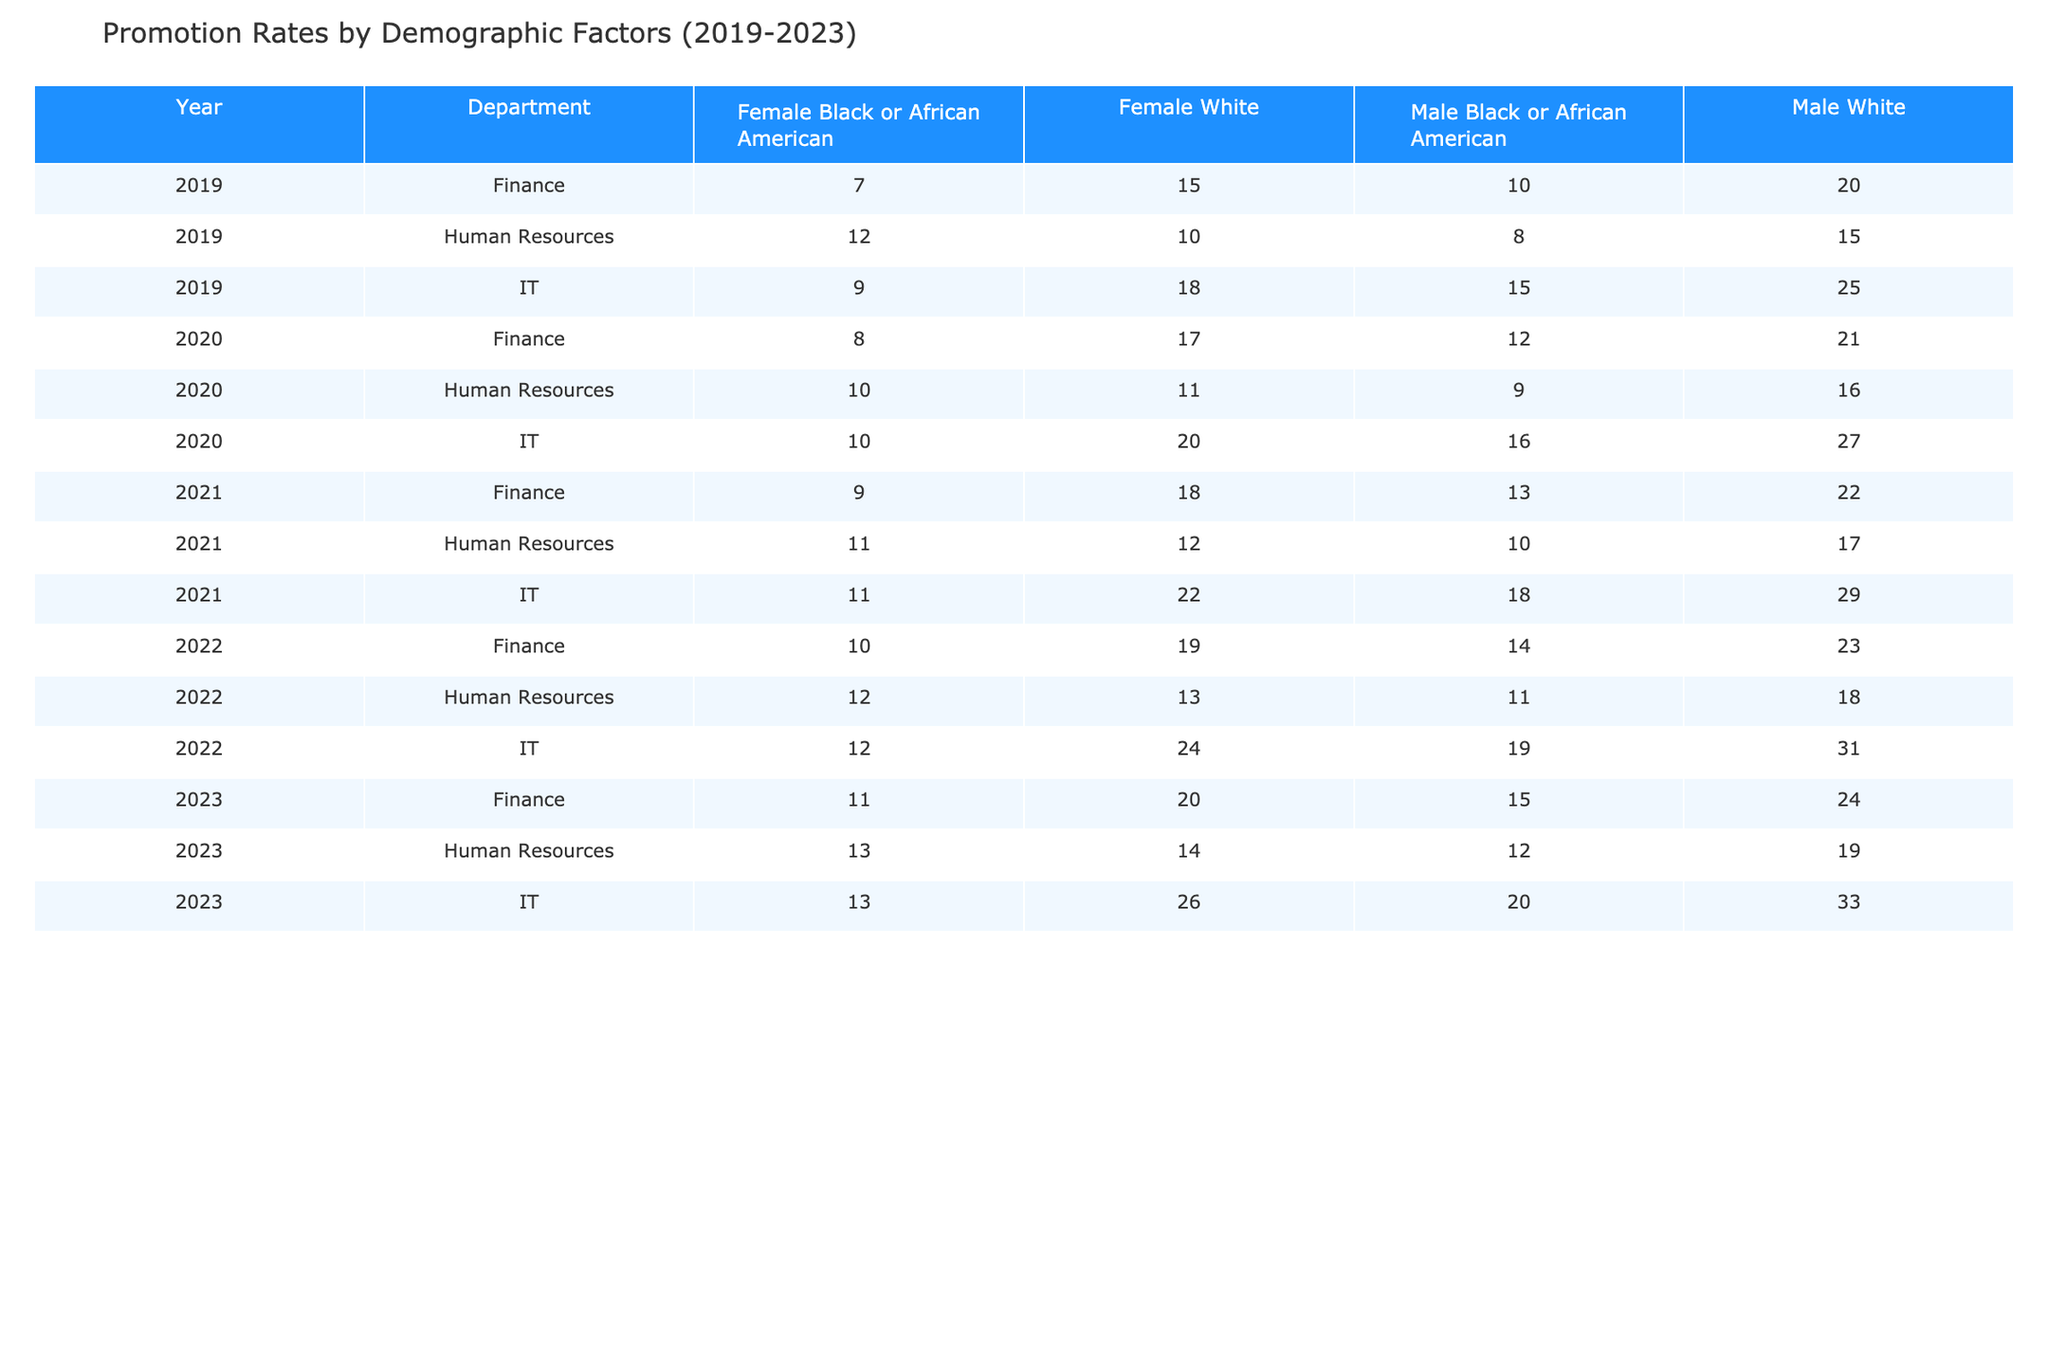What was the promotion rate for females of White ethnicity in IT in 2021? In the table, I locate the row for the year 2021, department IT, and find the column for females of White ethnicity. The promotion rate listed is 22.
Answer: 22 Which department had the highest promotion rate for Black or African American males in 2023? Looking at the year 2023, I check the promotion rates for Black or African American males across all departments. The highest rate is 20 in the IT department.
Answer: IT What is the average promotion rate for female employees (of all ethnicities combined) in Finance from 2019 to 2023? First, I sum the promotion rates for female employees in Finance over the years: 15 + 17 + 18 + 19 + 20 = 89. There are 5 data points, so I divide 89 by 5. The average is 89/5 = 17.8.
Answer: 17.8 Did the promotion rate for male employees of White ethnicity in Human Resources increase every year from 2019 to 2023? I examine the promotion rates for White males in Human Resources: 15 in 2019, 16 in 2020, 17 in 2021, 18 in 2022, and 19 in 2023. Since these values are increasing each year, the answer is yes.
Answer: Yes What was the difference in promotion rates for White females in IT between 2019 and 2022? I find the promotion rates for White females in IT. In 2019, it was 18, and in 2022, it was 24. The difference is calculated by subtracting the 2019 rate from the 2022 rate: 24 - 18 = 6.
Answer: 6 What was the highest promotion rate recorded for any demographic in Finance during the years 2019-2023? I scan the promotion rates in the Finance department for all years, identifying the highest value listed, which is 24 for White males in 2023.
Answer: 24 How did the promotion rate for Black or African American females in Human Resources change from 2019 to 2023? I check the rates for Black or African American females in Human Resources: 12 in 2019, 10 in 2020, 11 in 2021, 12 in 2022, and 13 in 2023. It shows an overall increase from 12 to 13 over the period.
Answer: Increased What is the overall trend in promotion rates for males of Black or African American ethnicity in the IT department from 2019 to 2023? I observe the promotion rates for Black or African American males in IT: 15 in 2019, 16 in 2020, 18 in 2021, 19 in 2022, and 20 in 2023. The values are consistently increasing year over year, indicating a positive trend.
Answer: Positive trend What was the promotion rate for females of Black or African American ethnicity in IT in 2022 and how does it compare to 2023? The promotion rate for Black or African American females in IT was 12 in 2022 and 13 in 2023. Comparing the two, there was an increase of 1 point.
Answer: 12 in 2022, 13 in 2023, increase of 1 Which gender and ethnicity combination had the lowest promotion rate in Finance in 2021? I check the Finance department for 2021: Black or African American females had the lowest promotion rate of 9.
Answer: Black or African American females What is the total promotion rate for all male employees (across all ethnicities) in Human Resources from 2019 to 2023? The rates for males in Human Resources for each year are: 15 (2019) + 16 (2020) + 17 (2021) + 18 (2022) + 19 (2023) = 85.
Answer: 85 